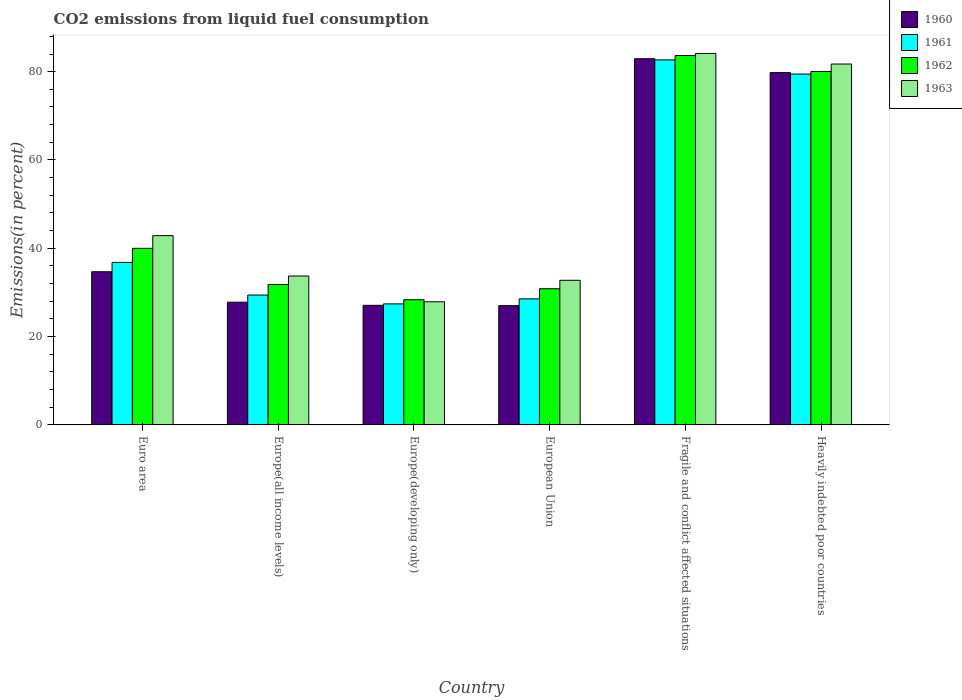How many groups of bars are there?
Give a very brief answer. 6. Are the number of bars on each tick of the X-axis equal?
Give a very brief answer. Yes. How many bars are there on the 6th tick from the right?
Your answer should be compact. 4. What is the label of the 6th group of bars from the left?
Your answer should be compact. Heavily indebted poor countries. What is the total CO2 emitted in 1962 in Europe(developing only)?
Ensure brevity in your answer.  28.35. Across all countries, what is the maximum total CO2 emitted in 1963?
Provide a succinct answer. 84.13. Across all countries, what is the minimum total CO2 emitted in 1960?
Your answer should be very brief. 27.01. In which country was the total CO2 emitted in 1963 maximum?
Give a very brief answer. Fragile and conflict affected situations. In which country was the total CO2 emitted in 1960 minimum?
Provide a short and direct response. European Union. What is the total total CO2 emitted in 1963 in the graph?
Provide a short and direct response. 303.09. What is the difference between the total CO2 emitted in 1960 in Euro area and that in Europe(all income levels)?
Your response must be concise. 6.9. What is the difference between the total CO2 emitted in 1963 in Euro area and the total CO2 emitted in 1962 in Fragile and conflict affected situations?
Offer a terse response. -40.78. What is the average total CO2 emitted in 1963 per country?
Give a very brief answer. 50.52. What is the difference between the total CO2 emitted of/in 1960 and total CO2 emitted of/in 1962 in Europe(all income levels)?
Give a very brief answer. -4.02. What is the ratio of the total CO2 emitted in 1960 in Euro area to that in Europe(developing only)?
Ensure brevity in your answer.  1.28. Is the difference between the total CO2 emitted in 1960 in European Union and Fragile and conflict affected situations greater than the difference between the total CO2 emitted in 1962 in European Union and Fragile and conflict affected situations?
Your answer should be very brief. No. What is the difference between the highest and the second highest total CO2 emitted in 1963?
Keep it short and to the point. 38.86. What is the difference between the highest and the lowest total CO2 emitted in 1962?
Provide a short and direct response. 55.3. In how many countries, is the total CO2 emitted in 1963 greater than the average total CO2 emitted in 1963 taken over all countries?
Give a very brief answer. 2. Is the sum of the total CO2 emitted in 1963 in Euro area and Europe(developing only) greater than the maximum total CO2 emitted in 1962 across all countries?
Offer a very short reply. No. Is it the case that in every country, the sum of the total CO2 emitted in 1963 and total CO2 emitted in 1961 is greater than the sum of total CO2 emitted in 1960 and total CO2 emitted in 1962?
Offer a terse response. No. What does the 2nd bar from the right in European Union represents?
Give a very brief answer. 1962. How many bars are there?
Keep it short and to the point. 24. Are all the bars in the graph horizontal?
Offer a terse response. No. What is the difference between two consecutive major ticks on the Y-axis?
Provide a succinct answer. 20. Are the values on the major ticks of Y-axis written in scientific E-notation?
Your answer should be very brief. No. Does the graph contain any zero values?
Give a very brief answer. No. Where does the legend appear in the graph?
Ensure brevity in your answer.  Top right. How many legend labels are there?
Offer a terse response. 4. What is the title of the graph?
Your answer should be very brief. CO2 emissions from liquid fuel consumption. What is the label or title of the Y-axis?
Provide a succinct answer. Emissions(in percent). What is the Emissions(in percent) of 1960 in Euro area?
Your answer should be very brief. 34.69. What is the Emissions(in percent) in 1961 in Euro area?
Provide a succinct answer. 36.81. What is the Emissions(in percent) of 1962 in Euro area?
Your answer should be very brief. 39.99. What is the Emissions(in percent) of 1963 in Euro area?
Give a very brief answer. 42.87. What is the Emissions(in percent) of 1960 in Europe(all income levels)?
Provide a succinct answer. 27.79. What is the Emissions(in percent) of 1961 in Europe(all income levels)?
Provide a short and direct response. 29.41. What is the Emissions(in percent) of 1962 in Europe(all income levels)?
Ensure brevity in your answer.  31.81. What is the Emissions(in percent) in 1963 in Europe(all income levels)?
Your response must be concise. 33.72. What is the Emissions(in percent) of 1960 in Europe(developing only)?
Offer a terse response. 27.08. What is the Emissions(in percent) in 1961 in Europe(developing only)?
Your answer should be very brief. 27.41. What is the Emissions(in percent) in 1962 in Europe(developing only)?
Your response must be concise. 28.35. What is the Emissions(in percent) of 1963 in Europe(developing only)?
Your answer should be very brief. 27.89. What is the Emissions(in percent) in 1960 in European Union?
Keep it short and to the point. 27.01. What is the Emissions(in percent) of 1961 in European Union?
Your answer should be very brief. 28.54. What is the Emissions(in percent) in 1962 in European Union?
Ensure brevity in your answer.  30.84. What is the Emissions(in percent) of 1963 in European Union?
Give a very brief answer. 32.75. What is the Emissions(in percent) in 1960 in Fragile and conflict affected situations?
Your answer should be very brief. 82.93. What is the Emissions(in percent) in 1961 in Fragile and conflict affected situations?
Offer a terse response. 82.67. What is the Emissions(in percent) in 1962 in Fragile and conflict affected situations?
Make the answer very short. 83.65. What is the Emissions(in percent) in 1963 in Fragile and conflict affected situations?
Your response must be concise. 84.13. What is the Emissions(in percent) in 1960 in Heavily indebted poor countries?
Provide a succinct answer. 79.79. What is the Emissions(in percent) of 1961 in Heavily indebted poor countries?
Your answer should be very brief. 79.46. What is the Emissions(in percent) in 1962 in Heavily indebted poor countries?
Your response must be concise. 80.05. What is the Emissions(in percent) of 1963 in Heavily indebted poor countries?
Provide a succinct answer. 81.73. Across all countries, what is the maximum Emissions(in percent) of 1960?
Your answer should be compact. 82.93. Across all countries, what is the maximum Emissions(in percent) in 1961?
Your answer should be compact. 82.67. Across all countries, what is the maximum Emissions(in percent) in 1962?
Provide a short and direct response. 83.65. Across all countries, what is the maximum Emissions(in percent) in 1963?
Offer a terse response. 84.13. Across all countries, what is the minimum Emissions(in percent) in 1960?
Offer a terse response. 27.01. Across all countries, what is the minimum Emissions(in percent) of 1961?
Offer a terse response. 27.41. Across all countries, what is the minimum Emissions(in percent) of 1962?
Provide a succinct answer. 28.35. Across all countries, what is the minimum Emissions(in percent) of 1963?
Your answer should be very brief. 27.89. What is the total Emissions(in percent) in 1960 in the graph?
Keep it short and to the point. 279.28. What is the total Emissions(in percent) of 1961 in the graph?
Provide a short and direct response. 284.31. What is the total Emissions(in percent) of 1962 in the graph?
Provide a short and direct response. 294.69. What is the total Emissions(in percent) in 1963 in the graph?
Give a very brief answer. 303.09. What is the difference between the Emissions(in percent) in 1960 in Euro area and that in Europe(all income levels)?
Offer a terse response. 6.9. What is the difference between the Emissions(in percent) of 1961 in Euro area and that in Europe(all income levels)?
Your response must be concise. 7.4. What is the difference between the Emissions(in percent) in 1962 in Euro area and that in Europe(all income levels)?
Your response must be concise. 8.18. What is the difference between the Emissions(in percent) of 1963 in Euro area and that in Europe(all income levels)?
Your answer should be very brief. 9.14. What is the difference between the Emissions(in percent) of 1960 in Euro area and that in Europe(developing only)?
Offer a very short reply. 7.6. What is the difference between the Emissions(in percent) of 1961 in Euro area and that in Europe(developing only)?
Keep it short and to the point. 9.4. What is the difference between the Emissions(in percent) of 1962 in Euro area and that in Europe(developing only)?
Ensure brevity in your answer.  11.64. What is the difference between the Emissions(in percent) in 1963 in Euro area and that in Europe(developing only)?
Your answer should be very brief. 14.98. What is the difference between the Emissions(in percent) of 1960 in Euro area and that in European Union?
Provide a succinct answer. 7.68. What is the difference between the Emissions(in percent) in 1961 in Euro area and that in European Union?
Make the answer very short. 8.27. What is the difference between the Emissions(in percent) in 1962 in Euro area and that in European Union?
Offer a terse response. 9.15. What is the difference between the Emissions(in percent) in 1963 in Euro area and that in European Union?
Offer a very short reply. 10.11. What is the difference between the Emissions(in percent) of 1960 in Euro area and that in Fragile and conflict affected situations?
Your response must be concise. -48.24. What is the difference between the Emissions(in percent) of 1961 in Euro area and that in Fragile and conflict affected situations?
Offer a terse response. -45.86. What is the difference between the Emissions(in percent) in 1962 in Euro area and that in Fragile and conflict affected situations?
Provide a short and direct response. -43.66. What is the difference between the Emissions(in percent) of 1963 in Euro area and that in Fragile and conflict affected situations?
Keep it short and to the point. -41.26. What is the difference between the Emissions(in percent) of 1960 in Euro area and that in Heavily indebted poor countries?
Give a very brief answer. -45.1. What is the difference between the Emissions(in percent) of 1961 in Euro area and that in Heavily indebted poor countries?
Give a very brief answer. -42.65. What is the difference between the Emissions(in percent) in 1962 in Euro area and that in Heavily indebted poor countries?
Provide a short and direct response. -40.06. What is the difference between the Emissions(in percent) in 1963 in Euro area and that in Heavily indebted poor countries?
Make the answer very short. -38.86. What is the difference between the Emissions(in percent) in 1960 in Europe(all income levels) and that in Europe(developing only)?
Your answer should be compact. 0.71. What is the difference between the Emissions(in percent) of 1961 in Europe(all income levels) and that in Europe(developing only)?
Your answer should be very brief. 2. What is the difference between the Emissions(in percent) of 1962 in Europe(all income levels) and that in Europe(developing only)?
Ensure brevity in your answer.  3.46. What is the difference between the Emissions(in percent) of 1963 in Europe(all income levels) and that in Europe(developing only)?
Your answer should be compact. 5.84. What is the difference between the Emissions(in percent) of 1960 in Europe(all income levels) and that in European Union?
Your answer should be compact. 0.78. What is the difference between the Emissions(in percent) of 1961 in Europe(all income levels) and that in European Union?
Your response must be concise. 0.87. What is the difference between the Emissions(in percent) of 1962 in Europe(all income levels) and that in European Union?
Offer a very short reply. 0.97. What is the difference between the Emissions(in percent) of 1963 in Europe(all income levels) and that in European Union?
Provide a succinct answer. 0.97. What is the difference between the Emissions(in percent) of 1960 in Europe(all income levels) and that in Fragile and conflict affected situations?
Ensure brevity in your answer.  -55.14. What is the difference between the Emissions(in percent) of 1961 in Europe(all income levels) and that in Fragile and conflict affected situations?
Offer a very short reply. -53.26. What is the difference between the Emissions(in percent) in 1962 in Europe(all income levels) and that in Fragile and conflict affected situations?
Provide a succinct answer. -51.84. What is the difference between the Emissions(in percent) of 1963 in Europe(all income levels) and that in Fragile and conflict affected situations?
Make the answer very short. -50.4. What is the difference between the Emissions(in percent) in 1960 in Europe(all income levels) and that in Heavily indebted poor countries?
Provide a succinct answer. -52. What is the difference between the Emissions(in percent) of 1961 in Europe(all income levels) and that in Heavily indebted poor countries?
Your answer should be compact. -50.05. What is the difference between the Emissions(in percent) in 1962 in Europe(all income levels) and that in Heavily indebted poor countries?
Your answer should be compact. -48.24. What is the difference between the Emissions(in percent) of 1963 in Europe(all income levels) and that in Heavily indebted poor countries?
Your answer should be very brief. -48.01. What is the difference between the Emissions(in percent) of 1960 in Europe(developing only) and that in European Union?
Ensure brevity in your answer.  0.07. What is the difference between the Emissions(in percent) in 1961 in Europe(developing only) and that in European Union?
Your answer should be compact. -1.13. What is the difference between the Emissions(in percent) in 1962 in Europe(developing only) and that in European Union?
Your answer should be compact. -2.49. What is the difference between the Emissions(in percent) of 1963 in Europe(developing only) and that in European Union?
Offer a very short reply. -4.87. What is the difference between the Emissions(in percent) in 1960 in Europe(developing only) and that in Fragile and conflict affected situations?
Provide a succinct answer. -55.85. What is the difference between the Emissions(in percent) in 1961 in Europe(developing only) and that in Fragile and conflict affected situations?
Provide a succinct answer. -55.26. What is the difference between the Emissions(in percent) in 1962 in Europe(developing only) and that in Fragile and conflict affected situations?
Keep it short and to the point. -55.3. What is the difference between the Emissions(in percent) of 1963 in Europe(developing only) and that in Fragile and conflict affected situations?
Ensure brevity in your answer.  -56.24. What is the difference between the Emissions(in percent) of 1960 in Europe(developing only) and that in Heavily indebted poor countries?
Provide a succinct answer. -52.7. What is the difference between the Emissions(in percent) in 1961 in Europe(developing only) and that in Heavily indebted poor countries?
Provide a short and direct response. -52.05. What is the difference between the Emissions(in percent) in 1962 in Europe(developing only) and that in Heavily indebted poor countries?
Your response must be concise. -51.7. What is the difference between the Emissions(in percent) of 1963 in Europe(developing only) and that in Heavily indebted poor countries?
Keep it short and to the point. -53.84. What is the difference between the Emissions(in percent) of 1960 in European Union and that in Fragile and conflict affected situations?
Offer a terse response. -55.92. What is the difference between the Emissions(in percent) of 1961 in European Union and that in Fragile and conflict affected situations?
Offer a very short reply. -54.12. What is the difference between the Emissions(in percent) in 1962 in European Union and that in Fragile and conflict affected situations?
Give a very brief answer. -52.81. What is the difference between the Emissions(in percent) in 1963 in European Union and that in Fragile and conflict affected situations?
Ensure brevity in your answer.  -51.37. What is the difference between the Emissions(in percent) in 1960 in European Union and that in Heavily indebted poor countries?
Make the answer very short. -52.78. What is the difference between the Emissions(in percent) of 1961 in European Union and that in Heavily indebted poor countries?
Keep it short and to the point. -50.91. What is the difference between the Emissions(in percent) in 1962 in European Union and that in Heavily indebted poor countries?
Your response must be concise. -49.21. What is the difference between the Emissions(in percent) of 1963 in European Union and that in Heavily indebted poor countries?
Provide a short and direct response. -48.98. What is the difference between the Emissions(in percent) in 1960 in Fragile and conflict affected situations and that in Heavily indebted poor countries?
Offer a terse response. 3.14. What is the difference between the Emissions(in percent) of 1961 in Fragile and conflict affected situations and that in Heavily indebted poor countries?
Ensure brevity in your answer.  3.21. What is the difference between the Emissions(in percent) in 1962 in Fragile and conflict affected situations and that in Heavily indebted poor countries?
Make the answer very short. 3.6. What is the difference between the Emissions(in percent) of 1963 in Fragile and conflict affected situations and that in Heavily indebted poor countries?
Make the answer very short. 2.4. What is the difference between the Emissions(in percent) in 1960 in Euro area and the Emissions(in percent) in 1961 in Europe(all income levels)?
Give a very brief answer. 5.27. What is the difference between the Emissions(in percent) in 1960 in Euro area and the Emissions(in percent) in 1962 in Europe(all income levels)?
Your answer should be very brief. 2.88. What is the difference between the Emissions(in percent) in 1960 in Euro area and the Emissions(in percent) in 1963 in Europe(all income levels)?
Your response must be concise. 0.96. What is the difference between the Emissions(in percent) of 1961 in Euro area and the Emissions(in percent) of 1962 in Europe(all income levels)?
Your answer should be very brief. 5. What is the difference between the Emissions(in percent) in 1961 in Euro area and the Emissions(in percent) in 1963 in Europe(all income levels)?
Keep it short and to the point. 3.09. What is the difference between the Emissions(in percent) of 1962 in Euro area and the Emissions(in percent) of 1963 in Europe(all income levels)?
Provide a succinct answer. 6.27. What is the difference between the Emissions(in percent) of 1960 in Euro area and the Emissions(in percent) of 1961 in Europe(developing only)?
Your answer should be very brief. 7.28. What is the difference between the Emissions(in percent) in 1960 in Euro area and the Emissions(in percent) in 1962 in Europe(developing only)?
Your answer should be compact. 6.34. What is the difference between the Emissions(in percent) in 1960 in Euro area and the Emissions(in percent) in 1963 in Europe(developing only)?
Make the answer very short. 6.8. What is the difference between the Emissions(in percent) of 1961 in Euro area and the Emissions(in percent) of 1962 in Europe(developing only)?
Your response must be concise. 8.46. What is the difference between the Emissions(in percent) of 1961 in Euro area and the Emissions(in percent) of 1963 in Europe(developing only)?
Ensure brevity in your answer.  8.92. What is the difference between the Emissions(in percent) in 1962 in Euro area and the Emissions(in percent) in 1963 in Europe(developing only)?
Offer a very short reply. 12.1. What is the difference between the Emissions(in percent) of 1960 in Euro area and the Emissions(in percent) of 1961 in European Union?
Make the answer very short. 6.14. What is the difference between the Emissions(in percent) of 1960 in Euro area and the Emissions(in percent) of 1962 in European Union?
Your answer should be very brief. 3.85. What is the difference between the Emissions(in percent) of 1960 in Euro area and the Emissions(in percent) of 1963 in European Union?
Your answer should be compact. 1.93. What is the difference between the Emissions(in percent) of 1961 in Euro area and the Emissions(in percent) of 1962 in European Union?
Give a very brief answer. 5.97. What is the difference between the Emissions(in percent) in 1961 in Euro area and the Emissions(in percent) in 1963 in European Union?
Ensure brevity in your answer.  4.06. What is the difference between the Emissions(in percent) of 1962 in Euro area and the Emissions(in percent) of 1963 in European Union?
Your response must be concise. 7.24. What is the difference between the Emissions(in percent) in 1960 in Euro area and the Emissions(in percent) in 1961 in Fragile and conflict affected situations?
Provide a succinct answer. -47.98. What is the difference between the Emissions(in percent) in 1960 in Euro area and the Emissions(in percent) in 1962 in Fragile and conflict affected situations?
Provide a succinct answer. -48.96. What is the difference between the Emissions(in percent) in 1960 in Euro area and the Emissions(in percent) in 1963 in Fragile and conflict affected situations?
Keep it short and to the point. -49.44. What is the difference between the Emissions(in percent) in 1961 in Euro area and the Emissions(in percent) in 1962 in Fragile and conflict affected situations?
Your answer should be compact. -46.84. What is the difference between the Emissions(in percent) in 1961 in Euro area and the Emissions(in percent) in 1963 in Fragile and conflict affected situations?
Ensure brevity in your answer.  -47.32. What is the difference between the Emissions(in percent) in 1962 in Euro area and the Emissions(in percent) in 1963 in Fragile and conflict affected situations?
Ensure brevity in your answer.  -44.13. What is the difference between the Emissions(in percent) of 1960 in Euro area and the Emissions(in percent) of 1961 in Heavily indebted poor countries?
Ensure brevity in your answer.  -44.77. What is the difference between the Emissions(in percent) in 1960 in Euro area and the Emissions(in percent) in 1962 in Heavily indebted poor countries?
Provide a succinct answer. -45.36. What is the difference between the Emissions(in percent) of 1960 in Euro area and the Emissions(in percent) of 1963 in Heavily indebted poor countries?
Your response must be concise. -47.04. What is the difference between the Emissions(in percent) in 1961 in Euro area and the Emissions(in percent) in 1962 in Heavily indebted poor countries?
Your response must be concise. -43.24. What is the difference between the Emissions(in percent) of 1961 in Euro area and the Emissions(in percent) of 1963 in Heavily indebted poor countries?
Your answer should be very brief. -44.92. What is the difference between the Emissions(in percent) in 1962 in Euro area and the Emissions(in percent) in 1963 in Heavily indebted poor countries?
Your answer should be very brief. -41.74. What is the difference between the Emissions(in percent) of 1960 in Europe(all income levels) and the Emissions(in percent) of 1961 in Europe(developing only)?
Provide a short and direct response. 0.38. What is the difference between the Emissions(in percent) of 1960 in Europe(all income levels) and the Emissions(in percent) of 1962 in Europe(developing only)?
Offer a very short reply. -0.56. What is the difference between the Emissions(in percent) of 1960 in Europe(all income levels) and the Emissions(in percent) of 1963 in Europe(developing only)?
Your answer should be compact. -0.1. What is the difference between the Emissions(in percent) of 1961 in Europe(all income levels) and the Emissions(in percent) of 1962 in Europe(developing only)?
Offer a terse response. 1.07. What is the difference between the Emissions(in percent) in 1961 in Europe(all income levels) and the Emissions(in percent) in 1963 in Europe(developing only)?
Your answer should be compact. 1.53. What is the difference between the Emissions(in percent) of 1962 in Europe(all income levels) and the Emissions(in percent) of 1963 in Europe(developing only)?
Provide a succinct answer. 3.92. What is the difference between the Emissions(in percent) in 1960 in Europe(all income levels) and the Emissions(in percent) in 1961 in European Union?
Your answer should be compact. -0.75. What is the difference between the Emissions(in percent) of 1960 in Europe(all income levels) and the Emissions(in percent) of 1962 in European Union?
Ensure brevity in your answer.  -3.05. What is the difference between the Emissions(in percent) in 1960 in Europe(all income levels) and the Emissions(in percent) in 1963 in European Union?
Offer a terse response. -4.96. What is the difference between the Emissions(in percent) of 1961 in Europe(all income levels) and the Emissions(in percent) of 1962 in European Union?
Make the answer very short. -1.43. What is the difference between the Emissions(in percent) of 1961 in Europe(all income levels) and the Emissions(in percent) of 1963 in European Union?
Your answer should be compact. -3.34. What is the difference between the Emissions(in percent) in 1962 in Europe(all income levels) and the Emissions(in percent) in 1963 in European Union?
Your answer should be very brief. -0.95. What is the difference between the Emissions(in percent) of 1960 in Europe(all income levels) and the Emissions(in percent) of 1961 in Fragile and conflict affected situations?
Your response must be concise. -54.88. What is the difference between the Emissions(in percent) in 1960 in Europe(all income levels) and the Emissions(in percent) in 1962 in Fragile and conflict affected situations?
Give a very brief answer. -55.86. What is the difference between the Emissions(in percent) of 1960 in Europe(all income levels) and the Emissions(in percent) of 1963 in Fragile and conflict affected situations?
Your response must be concise. -56.34. What is the difference between the Emissions(in percent) of 1961 in Europe(all income levels) and the Emissions(in percent) of 1962 in Fragile and conflict affected situations?
Ensure brevity in your answer.  -54.24. What is the difference between the Emissions(in percent) in 1961 in Europe(all income levels) and the Emissions(in percent) in 1963 in Fragile and conflict affected situations?
Provide a succinct answer. -54.71. What is the difference between the Emissions(in percent) of 1962 in Europe(all income levels) and the Emissions(in percent) of 1963 in Fragile and conflict affected situations?
Provide a succinct answer. -52.32. What is the difference between the Emissions(in percent) of 1960 in Europe(all income levels) and the Emissions(in percent) of 1961 in Heavily indebted poor countries?
Make the answer very short. -51.67. What is the difference between the Emissions(in percent) in 1960 in Europe(all income levels) and the Emissions(in percent) in 1962 in Heavily indebted poor countries?
Provide a succinct answer. -52.26. What is the difference between the Emissions(in percent) of 1960 in Europe(all income levels) and the Emissions(in percent) of 1963 in Heavily indebted poor countries?
Ensure brevity in your answer.  -53.94. What is the difference between the Emissions(in percent) in 1961 in Europe(all income levels) and the Emissions(in percent) in 1962 in Heavily indebted poor countries?
Ensure brevity in your answer.  -50.64. What is the difference between the Emissions(in percent) in 1961 in Europe(all income levels) and the Emissions(in percent) in 1963 in Heavily indebted poor countries?
Provide a short and direct response. -52.32. What is the difference between the Emissions(in percent) of 1962 in Europe(all income levels) and the Emissions(in percent) of 1963 in Heavily indebted poor countries?
Your response must be concise. -49.92. What is the difference between the Emissions(in percent) in 1960 in Europe(developing only) and the Emissions(in percent) in 1961 in European Union?
Your response must be concise. -1.46. What is the difference between the Emissions(in percent) of 1960 in Europe(developing only) and the Emissions(in percent) of 1962 in European Union?
Give a very brief answer. -3.76. What is the difference between the Emissions(in percent) in 1960 in Europe(developing only) and the Emissions(in percent) in 1963 in European Union?
Your answer should be very brief. -5.67. What is the difference between the Emissions(in percent) in 1961 in Europe(developing only) and the Emissions(in percent) in 1962 in European Union?
Ensure brevity in your answer.  -3.43. What is the difference between the Emissions(in percent) of 1961 in Europe(developing only) and the Emissions(in percent) of 1963 in European Union?
Make the answer very short. -5.34. What is the difference between the Emissions(in percent) of 1962 in Europe(developing only) and the Emissions(in percent) of 1963 in European Union?
Provide a succinct answer. -4.41. What is the difference between the Emissions(in percent) in 1960 in Europe(developing only) and the Emissions(in percent) in 1961 in Fragile and conflict affected situations?
Give a very brief answer. -55.59. What is the difference between the Emissions(in percent) of 1960 in Europe(developing only) and the Emissions(in percent) of 1962 in Fragile and conflict affected situations?
Your answer should be compact. -56.57. What is the difference between the Emissions(in percent) of 1960 in Europe(developing only) and the Emissions(in percent) of 1963 in Fragile and conflict affected situations?
Keep it short and to the point. -57.04. What is the difference between the Emissions(in percent) of 1961 in Europe(developing only) and the Emissions(in percent) of 1962 in Fragile and conflict affected situations?
Provide a succinct answer. -56.24. What is the difference between the Emissions(in percent) of 1961 in Europe(developing only) and the Emissions(in percent) of 1963 in Fragile and conflict affected situations?
Keep it short and to the point. -56.72. What is the difference between the Emissions(in percent) in 1962 in Europe(developing only) and the Emissions(in percent) in 1963 in Fragile and conflict affected situations?
Make the answer very short. -55.78. What is the difference between the Emissions(in percent) of 1960 in Europe(developing only) and the Emissions(in percent) of 1961 in Heavily indebted poor countries?
Keep it short and to the point. -52.38. What is the difference between the Emissions(in percent) in 1960 in Europe(developing only) and the Emissions(in percent) in 1962 in Heavily indebted poor countries?
Offer a terse response. -52.97. What is the difference between the Emissions(in percent) of 1960 in Europe(developing only) and the Emissions(in percent) of 1963 in Heavily indebted poor countries?
Your answer should be very brief. -54.65. What is the difference between the Emissions(in percent) in 1961 in Europe(developing only) and the Emissions(in percent) in 1962 in Heavily indebted poor countries?
Keep it short and to the point. -52.64. What is the difference between the Emissions(in percent) in 1961 in Europe(developing only) and the Emissions(in percent) in 1963 in Heavily indebted poor countries?
Your response must be concise. -54.32. What is the difference between the Emissions(in percent) of 1962 in Europe(developing only) and the Emissions(in percent) of 1963 in Heavily indebted poor countries?
Your response must be concise. -53.38. What is the difference between the Emissions(in percent) in 1960 in European Union and the Emissions(in percent) in 1961 in Fragile and conflict affected situations?
Your answer should be very brief. -55.66. What is the difference between the Emissions(in percent) in 1960 in European Union and the Emissions(in percent) in 1962 in Fragile and conflict affected situations?
Your answer should be compact. -56.64. What is the difference between the Emissions(in percent) in 1960 in European Union and the Emissions(in percent) in 1963 in Fragile and conflict affected situations?
Ensure brevity in your answer.  -57.12. What is the difference between the Emissions(in percent) in 1961 in European Union and the Emissions(in percent) in 1962 in Fragile and conflict affected situations?
Your answer should be very brief. -55.11. What is the difference between the Emissions(in percent) in 1961 in European Union and the Emissions(in percent) in 1963 in Fragile and conflict affected situations?
Offer a terse response. -55.58. What is the difference between the Emissions(in percent) in 1962 in European Union and the Emissions(in percent) in 1963 in Fragile and conflict affected situations?
Keep it short and to the point. -53.29. What is the difference between the Emissions(in percent) of 1960 in European Union and the Emissions(in percent) of 1961 in Heavily indebted poor countries?
Provide a short and direct response. -52.45. What is the difference between the Emissions(in percent) of 1960 in European Union and the Emissions(in percent) of 1962 in Heavily indebted poor countries?
Provide a succinct answer. -53.04. What is the difference between the Emissions(in percent) of 1960 in European Union and the Emissions(in percent) of 1963 in Heavily indebted poor countries?
Provide a short and direct response. -54.72. What is the difference between the Emissions(in percent) of 1961 in European Union and the Emissions(in percent) of 1962 in Heavily indebted poor countries?
Your answer should be compact. -51.51. What is the difference between the Emissions(in percent) in 1961 in European Union and the Emissions(in percent) in 1963 in Heavily indebted poor countries?
Your answer should be compact. -53.19. What is the difference between the Emissions(in percent) in 1962 in European Union and the Emissions(in percent) in 1963 in Heavily indebted poor countries?
Ensure brevity in your answer.  -50.89. What is the difference between the Emissions(in percent) in 1960 in Fragile and conflict affected situations and the Emissions(in percent) in 1961 in Heavily indebted poor countries?
Your answer should be compact. 3.47. What is the difference between the Emissions(in percent) in 1960 in Fragile and conflict affected situations and the Emissions(in percent) in 1962 in Heavily indebted poor countries?
Provide a succinct answer. 2.88. What is the difference between the Emissions(in percent) of 1960 in Fragile and conflict affected situations and the Emissions(in percent) of 1963 in Heavily indebted poor countries?
Provide a succinct answer. 1.2. What is the difference between the Emissions(in percent) in 1961 in Fragile and conflict affected situations and the Emissions(in percent) in 1962 in Heavily indebted poor countries?
Offer a terse response. 2.62. What is the difference between the Emissions(in percent) of 1961 in Fragile and conflict affected situations and the Emissions(in percent) of 1963 in Heavily indebted poor countries?
Make the answer very short. 0.94. What is the difference between the Emissions(in percent) in 1962 in Fragile and conflict affected situations and the Emissions(in percent) in 1963 in Heavily indebted poor countries?
Offer a very short reply. 1.92. What is the average Emissions(in percent) of 1960 per country?
Your response must be concise. 46.55. What is the average Emissions(in percent) of 1961 per country?
Your response must be concise. 47.38. What is the average Emissions(in percent) in 1962 per country?
Give a very brief answer. 49.11. What is the average Emissions(in percent) of 1963 per country?
Your answer should be compact. 50.52. What is the difference between the Emissions(in percent) of 1960 and Emissions(in percent) of 1961 in Euro area?
Offer a terse response. -2.12. What is the difference between the Emissions(in percent) in 1960 and Emissions(in percent) in 1962 in Euro area?
Provide a succinct answer. -5.3. What is the difference between the Emissions(in percent) of 1960 and Emissions(in percent) of 1963 in Euro area?
Your answer should be compact. -8.18. What is the difference between the Emissions(in percent) of 1961 and Emissions(in percent) of 1962 in Euro area?
Offer a terse response. -3.18. What is the difference between the Emissions(in percent) of 1961 and Emissions(in percent) of 1963 in Euro area?
Offer a terse response. -6.06. What is the difference between the Emissions(in percent) of 1962 and Emissions(in percent) of 1963 in Euro area?
Offer a terse response. -2.88. What is the difference between the Emissions(in percent) in 1960 and Emissions(in percent) in 1961 in Europe(all income levels)?
Offer a terse response. -1.62. What is the difference between the Emissions(in percent) of 1960 and Emissions(in percent) of 1962 in Europe(all income levels)?
Your answer should be compact. -4.02. What is the difference between the Emissions(in percent) of 1960 and Emissions(in percent) of 1963 in Europe(all income levels)?
Offer a terse response. -5.93. What is the difference between the Emissions(in percent) of 1961 and Emissions(in percent) of 1962 in Europe(all income levels)?
Give a very brief answer. -2.39. What is the difference between the Emissions(in percent) of 1961 and Emissions(in percent) of 1963 in Europe(all income levels)?
Your response must be concise. -4.31. What is the difference between the Emissions(in percent) in 1962 and Emissions(in percent) in 1963 in Europe(all income levels)?
Provide a succinct answer. -1.92. What is the difference between the Emissions(in percent) in 1960 and Emissions(in percent) in 1961 in Europe(developing only)?
Ensure brevity in your answer.  -0.33. What is the difference between the Emissions(in percent) in 1960 and Emissions(in percent) in 1962 in Europe(developing only)?
Your answer should be very brief. -1.26. What is the difference between the Emissions(in percent) in 1960 and Emissions(in percent) in 1963 in Europe(developing only)?
Keep it short and to the point. -0.8. What is the difference between the Emissions(in percent) of 1961 and Emissions(in percent) of 1962 in Europe(developing only)?
Offer a very short reply. -0.94. What is the difference between the Emissions(in percent) in 1961 and Emissions(in percent) in 1963 in Europe(developing only)?
Keep it short and to the point. -0.48. What is the difference between the Emissions(in percent) of 1962 and Emissions(in percent) of 1963 in Europe(developing only)?
Keep it short and to the point. 0.46. What is the difference between the Emissions(in percent) of 1960 and Emissions(in percent) of 1961 in European Union?
Your answer should be very brief. -1.54. What is the difference between the Emissions(in percent) in 1960 and Emissions(in percent) in 1962 in European Union?
Offer a terse response. -3.83. What is the difference between the Emissions(in percent) of 1960 and Emissions(in percent) of 1963 in European Union?
Provide a succinct answer. -5.75. What is the difference between the Emissions(in percent) of 1961 and Emissions(in percent) of 1962 in European Union?
Your answer should be very brief. -2.3. What is the difference between the Emissions(in percent) in 1961 and Emissions(in percent) in 1963 in European Union?
Your answer should be very brief. -4.21. What is the difference between the Emissions(in percent) in 1962 and Emissions(in percent) in 1963 in European Union?
Your answer should be compact. -1.91. What is the difference between the Emissions(in percent) of 1960 and Emissions(in percent) of 1961 in Fragile and conflict affected situations?
Give a very brief answer. 0.26. What is the difference between the Emissions(in percent) of 1960 and Emissions(in percent) of 1962 in Fragile and conflict affected situations?
Keep it short and to the point. -0.72. What is the difference between the Emissions(in percent) of 1960 and Emissions(in percent) of 1963 in Fragile and conflict affected situations?
Ensure brevity in your answer.  -1.2. What is the difference between the Emissions(in percent) in 1961 and Emissions(in percent) in 1962 in Fragile and conflict affected situations?
Offer a terse response. -0.98. What is the difference between the Emissions(in percent) of 1961 and Emissions(in percent) of 1963 in Fragile and conflict affected situations?
Offer a very short reply. -1.46. What is the difference between the Emissions(in percent) of 1962 and Emissions(in percent) of 1963 in Fragile and conflict affected situations?
Keep it short and to the point. -0.47. What is the difference between the Emissions(in percent) in 1960 and Emissions(in percent) in 1961 in Heavily indebted poor countries?
Provide a short and direct response. 0.33. What is the difference between the Emissions(in percent) of 1960 and Emissions(in percent) of 1962 in Heavily indebted poor countries?
Provide a succinct answer. -0.26. What is the difference between the Emissions(in percent) in 1960 and Emissions(in percent) in 1963 in Heavily indebted poor countries?
Provide a succinct answer. -1.95. What is the difference between the Emissions(in percent) of 1961 and Emissions(in percent) of 1962 in Heavily indebted poor countries?
Ensure brevity in your answer.  -0.59. What is the difference between the Emissions(in percent) of 1961 and Emissions(in percent) of 1963 in Heavily indebted poor countries?
Offer a very short reply. -2.27. What is the difference between the Emissions(in percent) of 1962 and Emissions(in percent) of 1963 in Heavily indebted poor countries?
Your response must be concise. -1.68. What is the ratio of the Emissions(in percent) of 1960 in Euro area to that in Europe(all income levels)?
Your answer should be very brief. 1.25. What is the ratio of the Emissions(in percent) of 1961 in Euro area to that in Europe(all income levels)?
Make the answer very short. 1.25. What is the ratio of the Emissions(in percent) in 1962 in Euro area to that in Europe(all income levels)?
Provide a succinct answer. 1.26. What is the ratio of the Emissions(in percent) of 1963 in Euro area to that in Europe(all income levels)?
Give a very brief answer. 1.27. What is the ratio of the Emissions(in percent) in 1960 in Euro area to that in Europe(developing only)?
Offer a very short reply. 1.28. What is the ratio of the Emissions(in percent) of 1961 in Euro area to that in Europe(developing only)?
Offer a terse response. 1.34. What is the ratio of the Emissions(in percent) in 1962 in Euro area to that in Europe(developing only)?
Offer a very short reply. 1.41. What is the ratio of the Emissions(in percent) in 1963 in Euro area to that in Europe(developing only)?
Keep it short and to the point. 1.54. What is the ratio of the Emissions(in percent) of 1960 in Euro area to that in European Union?
Your answer should be compact. 1.28. What is the ratio of the Emissions(in percent) in 1961 in Euro area to that in European Union?
Ensure brevity in your answer.  1.29. What is the ratio of the Emissions(in percent) of 1962 in Euro area to that in European Union?
Provide a succinct answer. 1.3. What is the ratio of the Emissions(in percent) in 1963 in Euro area to that in European Union?
Provide a succinct answer. 1.31. What is the ratio of the Emissions(in percent) of 1960 in Euro area to that in Fragile and conflict affected situations?
Provide a succinct answer. 0.42. What is the ratio of the Emissions(in percent) of 1961 in Euro area to that in Fragile and conflict affected situations?
Offer a terse response. 0.45. What is the ratio of the Emissions(in percent) of 1962 in Euro area to that in Fragile and conflict affected situations?
Provide a succinct answer. 0.48. What is the ratio of the Emissions(in percent) in 1963 in Euro area to that in Fragile and conflict affected situations?
Offer a very short reply. 0.51. What is the ratio of the Emissions(in percent) of 1960 in Euro area to that in Heavily indebted poor countries?
Your answer should be compact. 0.43. What is the ratio of the Emissions(in percent) in 1961 in Euro area to that in Heavily indebted poor countries?
Offer a terse response. 0.46. What is the ratio of the Emissions(in percent) of 1962 in Euro area to that in Heavily indebted poor countries?
Your response must be concise. 0.5. What is the ratio of the Emissions(in percent) in 1963 in Euro area to that in Heavily indebted poor countries?
Your answer should be very brief. 0.52. What is the ratio of the Emissions(in percent) in 1960 in Europe(all income levels) to that in Europe(developing only)?
Your response must be concise. 1.03. What is the ratio of the Emissions(in percent) of 1961 in Europe(all income levels) to that in Europe(developing only)?
Your answer should be very brief. 1.07. What is the ratio of the Emissions(in percent) of 1962 in Europe(all income levels) to that in Europe(developing only)?
Offer a terse response. 1.12. What is the ratio of the Emissions(in percent) in 1963 in Europe(all income levels) to that in Europe(developing only)?
Make the answer very short. 1.21. What is the ratio of the Emissions(in percent) of 1960 in Europe(all income levels) to that in European Union?
Your response must be concise. 1.03. What is the ratio of the Emissions(in percent) in 1961 in Europe(all income levels) to that in European Union?
Offer a terse response. 1.03. What is the ratio of the Emissions(in percent) in 1962 in Europe(all income levels) to that in European Union?
Offer a very short reply. 1.03. What is the ratio of the Emissions(in percent) in 1963 in Europe(all income levels) to that in European Union?
Ensure brevity in your answer.  1.03. What is the ratio of the Emissions(in percent) of 1960 in Europe(all income levels) to that in Fragile and conflict affected situations?
Offer a very short reply. 0.34. What is the ratio of the Emissions(in percent) in 1961 in Europe(all income levels) to that in Fragile and conflict affected situations?
Keep it short and to the point. 0.36. What is the ratio of the Emissions(in percent) in 1962 in Europe(all income levels) to that in Fragile and conflict affected situations?
Your answer should be compact. 0.38. What is the ratio of the Emissions(in percent) in 1963 in Europe(all income levels) to that in Fragile and conflict affected situations?
Your response must be concise. 0.4. What is the ratio of the Emissions(in percent) of 1960 in Europe(all income levels) to that in Heavily indebted poor countries?
Offer a very short reply. 0.35. What is the ratio of the Emissions(in percent) in 1961 in Europe(all income levels) to that in Heavily indebted poor countries?
Keep it short and to the point. 0.37. What is the ratio of the Emissions(in percent) in 1962 in Europe(all income levels) to that in Heavily indebted poor countries?
Provide a succinct answer. 0.4. What is the ratio of the Emissions(in percent) of 1963 in Europe(all income levels) to that in Heavily indebted poor countries?
Keep it short and to the point. 0.41. What is the ratio of the Emissions(in percent) of 1960 in Europe(developing only) to that in European Union?
Your response must be concise. 1. What is the ratio of the Emissions(in percent) of 1961 in Europe(developing only) to that in European Union?
Ensure brevity in your answer.  0.96. What is the ratio of the Emissions(in percent) of 1962 in Europe(developing only) to that in European Union?
Make the answer very short. 0.92. What is the ratio of the Emissions(in percent) in 1963 in Europe(developing only) to that in European Union?
Ensure brevity in your answer.  0.85. What is the ratio of the Emissions(in percent) in 1960 in Europe(developing only) to that in Fragile and conflict affected situations?
Give a very brief answer. 0.33. What is the ratio of the Emissions(in percent) of 1961 in Europe(developing only) to that in Fragile and conflict affected situations?
Your answer should be very brief. 0.33. What is the ratio of the Emissions(in percent) in 1962 in Europe(developing only) to that in Fragile and conflict affected situations?
Keep it short and to the point. 0.34. What is the ratio of the Emissions(in percent) of 1963 in Europe(developing only) to that in Fragile and conflict affected situations?
Your answer should be compact. 0.33. What is the ratio of the Emissions(in percent) of 1960 in Europe(developing only) to that in Heavily indebted poor countries?
Make the answer very short. 0.34. What is the ratio of the Emissions(in percent) of 1961 in Europe(developing only) to that in Heavily indebted poor countries?
Your answer should be very brief. 0.34. What is the ratio of the Emissions(in percent) in 1962 in Europe(developing only) to that in Heavily indebted poor countries?
Offer a terse response. 0.35. What is the ratio of the Emissions(in percent) in 1963 in Europe(developing only) to that in Heavily indebted poor countries?
Make the answer very short. 0.34. What is the ratio of the Emissions(in percent) of 1960 in European Union to that in Fragile and conflict affected situations?
Provide a short and direct response. 0.33. What is the ratio of the Emissions(in percent) of 1961 in European Union to that in Fragile and conflict affected situations?
Keep it short and to the point. 0.35. What is the ratio of the Emissions(in percent) of 1962 in European Union to that in Fragile and conflict affected situations?
Make the answer very short. 0.37. What is the ratio of the Emissions(in percent) in 1963 in European Union to that in Fragile and conflict affected situations?
Your answer should be compact. 0.39. What is the ratio of the Emissions(in percent) in 1960 in European Union to that in Heavily indebted poor countries?
Make the answer very short. 0.34. What is the ratio of the Emissions(in percent) in 1961 in European Union to that in Heavily indebted poor countries?
Keep it short and to the point. 0.36. What is the ratio of the Emissions(in percent) of 1962 in European Union to that in Heavily indebted poor countries?
Offer a very short reply. 0.39. What is the ratio of the Emissions(in percent) in 1963 in European Union to that in Heavily indebted poor countries?
Your response must be concise. 0.4. What is the ratio of the Emissions(in percent) in 1960 in Fragile and conflict affected situations to that in Heavily indebted poor countries?
Your answer should be very brief. 1.04. What is the ratio of the Emissions(in percent) of 1961 in Fragile and conflict affected situations to that in Heavily indebted poor countries?
Give a very brief answer. 1.04. What is the ratio of the Emissions(in percent) in 1962 in Fragile and conflict affected situations to that in Heavily indebted poor countries?
Provide a short and direct response. 1.04. What is the ratio of the Emissions(in percent) of 1963 in Fragile and conflict affected situations to that in Heavily indebted poor countries?
Make the answer very short. 1.03. What is the difference between the highest and the second highest Emissions(in percent) in 1960?
Your answer should be very brief. 3.14. What is the difference between the highest and the second highest Emissions(in percent) of 1961?
Provide a short and direct response. 3.21. What is the difference between the highest and the second highest Emissions(in percent) in 1962?
Offer a very short reply. 3.6. What is the difference between the highest and the second highest Emissions(in percent) in 1963?
Make the answer very short. 2.4. What is the difference between the highest and the lowest Emissions(in percent) of 1960?
Keep it short and to the point. 55.92. What is the difference between the highest and the lowest Emissions(in percent) in 1961?
Your answer should be very brief. 55.26. What is the difference between the highest and the lowest Emissions(in percent) in 1962?
Your answer should be very brief. 55.3. What is the difference between the highest and the lowest Emissions(in percent) of 1963?
Ensure brevity in your answer.  56.24. 